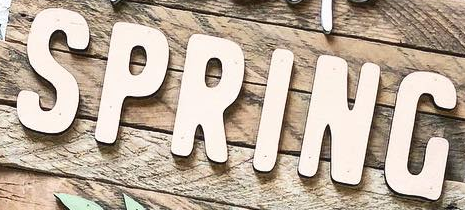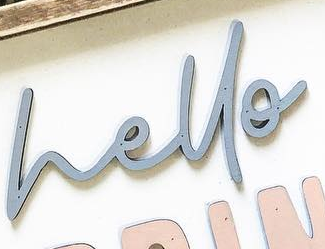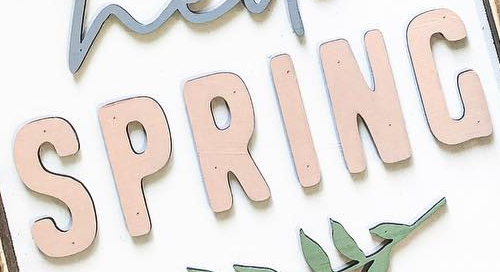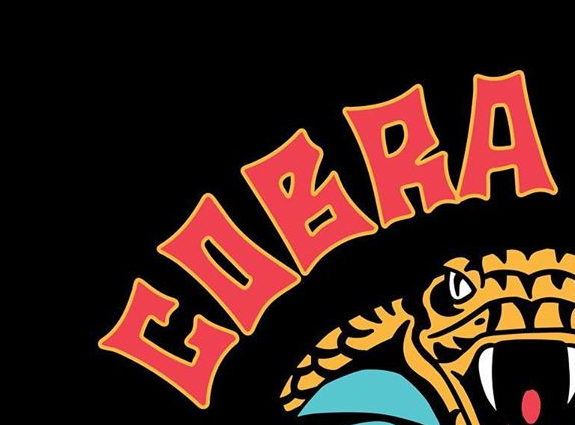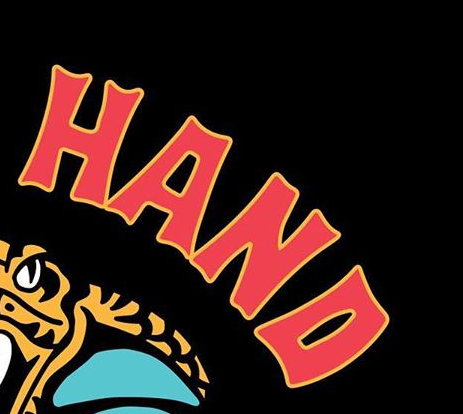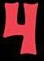Read the text from these images in sequence, separated by a semicolon. SPRING; hello; SPRING; COBRA; HAND; 4 